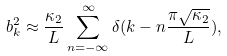<formula> <loc_0><loc_0><loc_500><loc_500>b _ { k } ^ { 2 } \approx \frac { \kappa _ { 2 } } { L } \sum _ { n = - \infty } ^ { \infty } \delta ( k - n \frac { \pi \sqrt { \kappa _ { 2 } } } { L } ) ,</formula> 